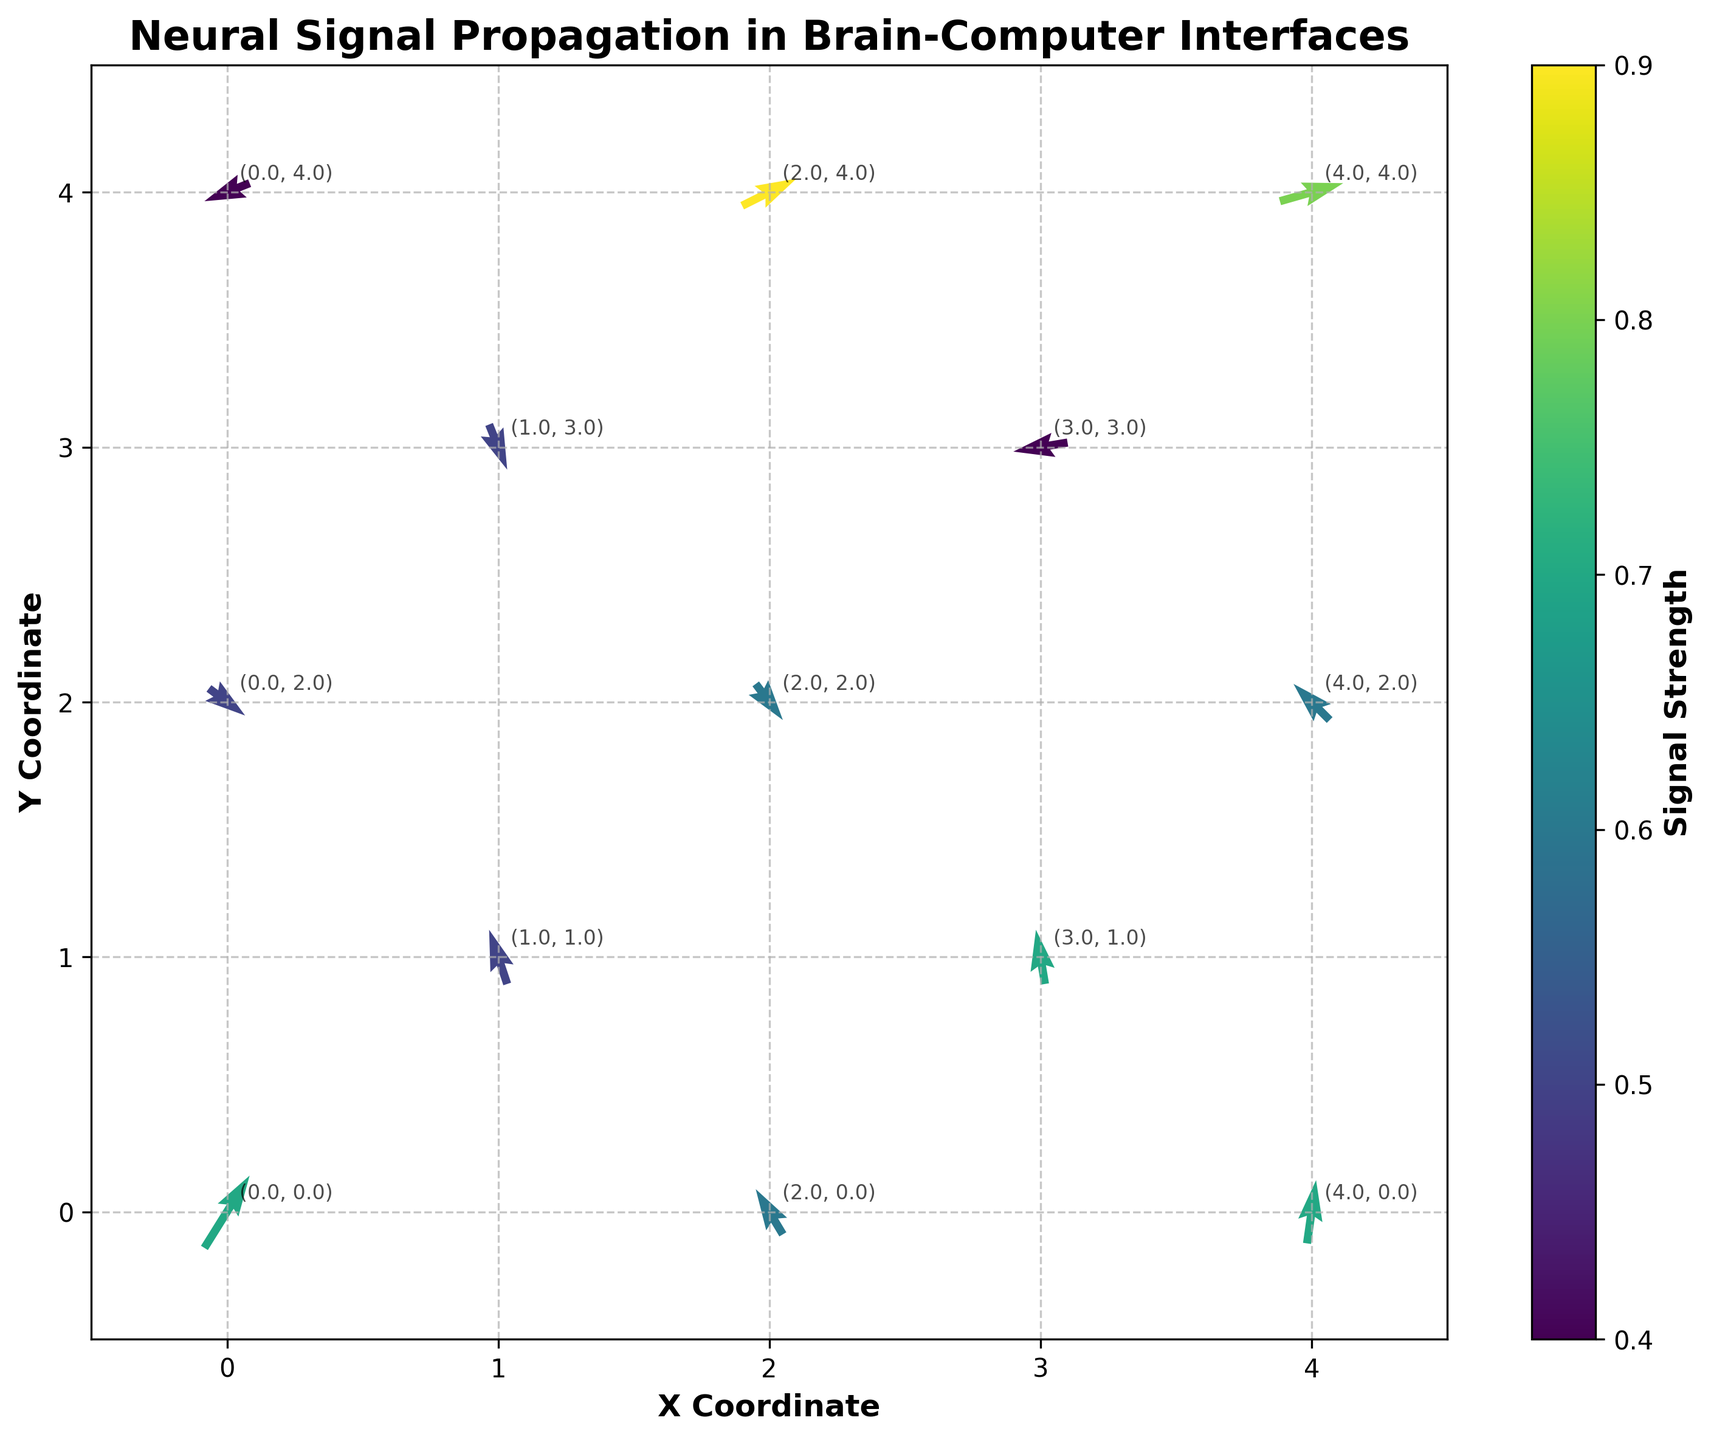What's the title of the figure? The title is usually located at the top of the figure, often in bold and slightly larger font than other text. In this case, it reads "Neural Signal Propagation in Brain-Computer Interfaces".
Answer: Neural Signal Propagation in Brain-Computer Interfaces How many data points are represented in the figure? To determine the number of data points, one can count the arrows or vectors in the quiver plot. Each arrow represents a data point. Based on the provided data, there are 12 data points.
Answer: 12 What is the color bar representing? The color bar usually has a label, which in this case reads "Signal Strength". Based on this, the color bar represents the strength of the neural signals.
Answer: Signal Strength What are the x and y coordinate ranges shown in the figure? By checking the x and y axes' limits or endpoints, we can see the minimum and maximum values for both coordinates. The x-axis ranges from -0.5 to 4.5, and the same applies to the y-axis.
Answer: -0.5 to 4.5 for both axes Which point has the strongest signal strength and what is its value? By examining the color bar and the arrows' colors, the strongest signal strength corresponds to the brightest or most intense color. From the data, the maximum `signal_strength` value is 0.9 at the point (2, 4).
Answer: (2, 4), 0.9 Which vector has the smallest magnitude, and what is its value? To determine the vector with the smallest magnitude, compute the magnitude of each vector using the formula sqrt(u^2 + v^2). The smallest magnitude is observed for the vector with u=-0.6, v=-0.1 at point (3, 3), and it is sqrt(0.6^2 + 0.1^2) ≈ 0.608.
Answer: Vector at point (3, 3), ~0.608 Is there a point where the signal is directed upwards (positive y-component) with a strength greater than 0.6? From the data, check the values of `v` (positive indicates upward direction) and `signal_strength` to see if both conditions are met. The point (0, 0) has `v`=0.8 and `signal_strength`=0.7, satisfying the conditions.
Answer: Yes, at (0, 0) Which two points have vectors pointing in opposite directions? Check vectors' direction by examining their `u` and `v` values; opposite directions have u and v components with opposite signs. For instance, (1, 1) has u=-0.2, v=0.6 and (3, 3) has u=-0.6, v=-0.1 indicating opposite pointing vectors.
Answer: (1, 1) and (3, 3) What's the average signal strength of the vectors pointing rightwards (positive x-component)? Identify vectors with positive `u` values: (0, 0), (2, 2), (4, 4), (0, 2), (4, 0), (2, 4). Average their `signal_strength`: (0.7 + 0.6 + 0.8 + 0.5 + 0.7 + 0.9) / 6 ≈ 0.7.
Answer: ~0.7 What is the direction and signal strength of the vector at (4, 4)? The provided data lists the vector at (4, 4) with u=0.7, v=0.2, indicating its direction. The `signal_strength` for this vector is 0.8.
Answer: Right and slightly up, 0.8 